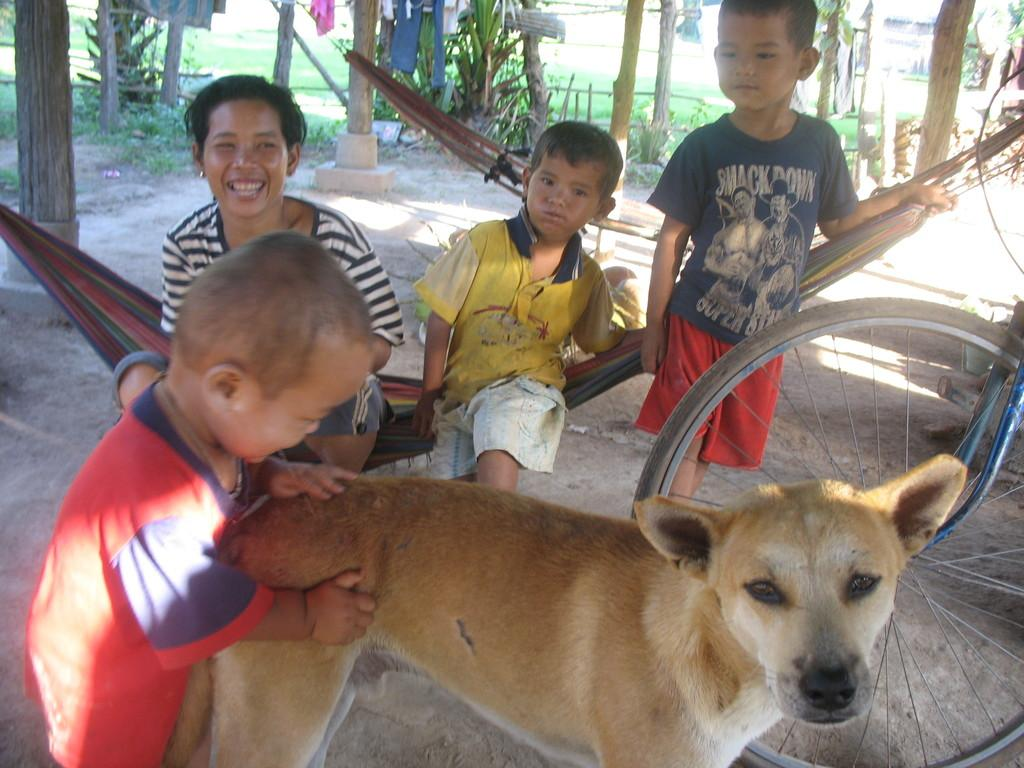How many people are in the image? There are four persons in the image. What other living creature is present in the image? There is a dog in the image. What type of playground equipment can be seen in the image? There is a swing in the image. What mechanical object is visible in the image? There is a wheel in the image. What type of natural environment is visible in the image? There is grass visible in the image. What type of vegetation is present in the image? There are plants in the image. How many minutes does it take for the square to jump over the frogs in the image? There is no square or frogs present in the image, so this question cannot be answered. 